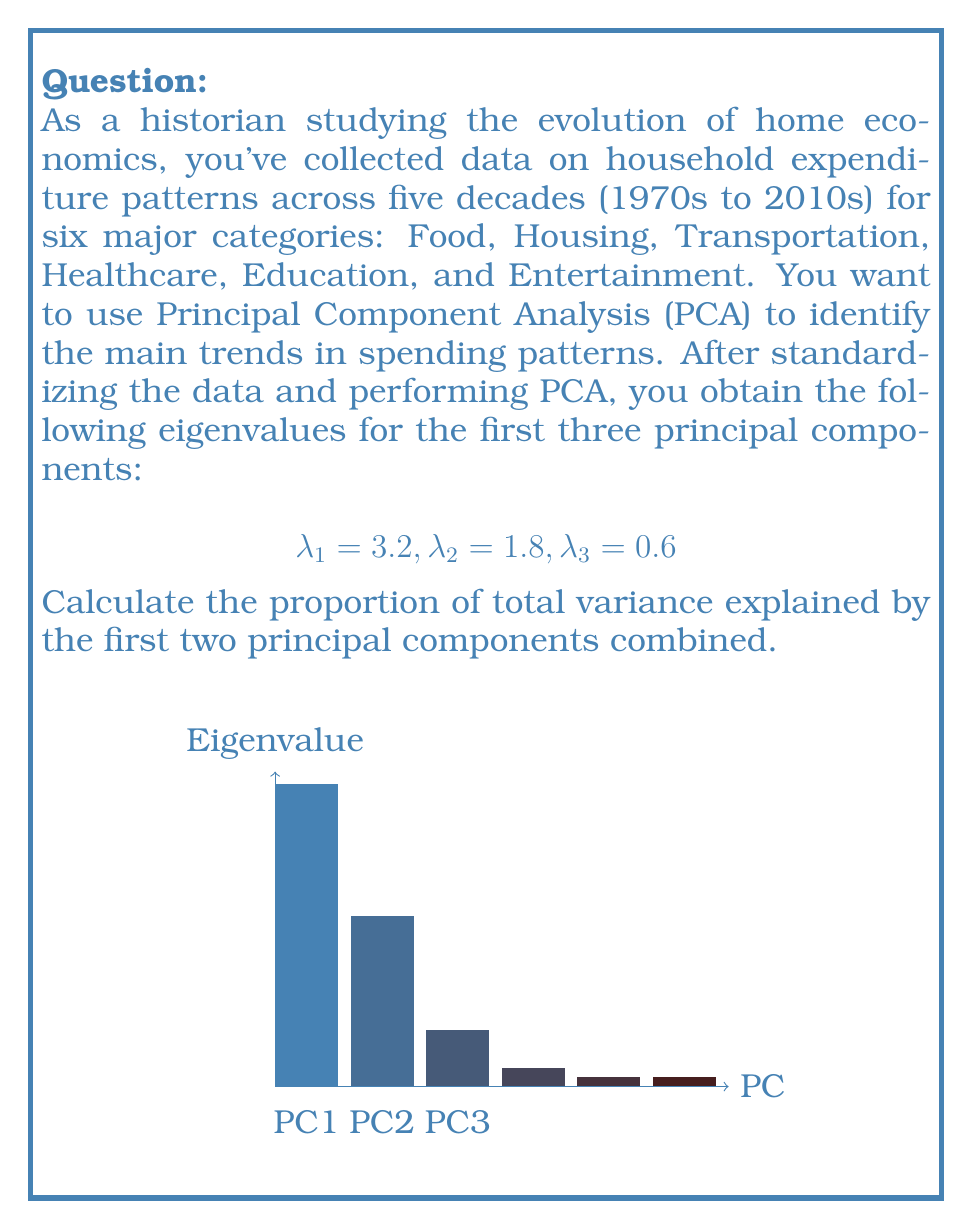Give your solution to this math problem. To solve this problem, we'll follow these steps:

1) First, recall that in PCA, each eigenvalue represents the amount of variance explained by its corresponding principal component.

2) The total variance in a dataset with standardized variables is equal to the number of variables. In this case, we have 6 variables (categories of expenditure), so the total variance is 6.

3) To calculate the proportion of variance explained by a principal component, we divide its eigenvalue by the total variance:

   Proportion of variance explained by PC1 = $\frac{\lambda_1}{6} = \frac{3.2}{6}$
   Proportion of variance explained by PC2 = $\frac{\lambda_2}{6} = \frac{1.8}{6}$

4) To find the proportion of variance explained by the first two principal components combined, we add these proportions:

   $$\frac{\lambda_1 + \lambda_2}{6} = \frac{3.2 + 1.8}{6} = \frac{5}{6}$$

5) We can simplify this fraction:

   $$\frac{5}{6} = 0.8333...$$

6) Therefore, the first two principal components combined explain approximately 83.33% of the total variance in the household expenditure patterns across the five decades.

This high proportion suggests that these two components capture the majority of the trends in household spending over time, which could provide valuable insights for your historical analysis of home economics.
Answer: $\frac{5}{6}$ or approximately 83.33% 